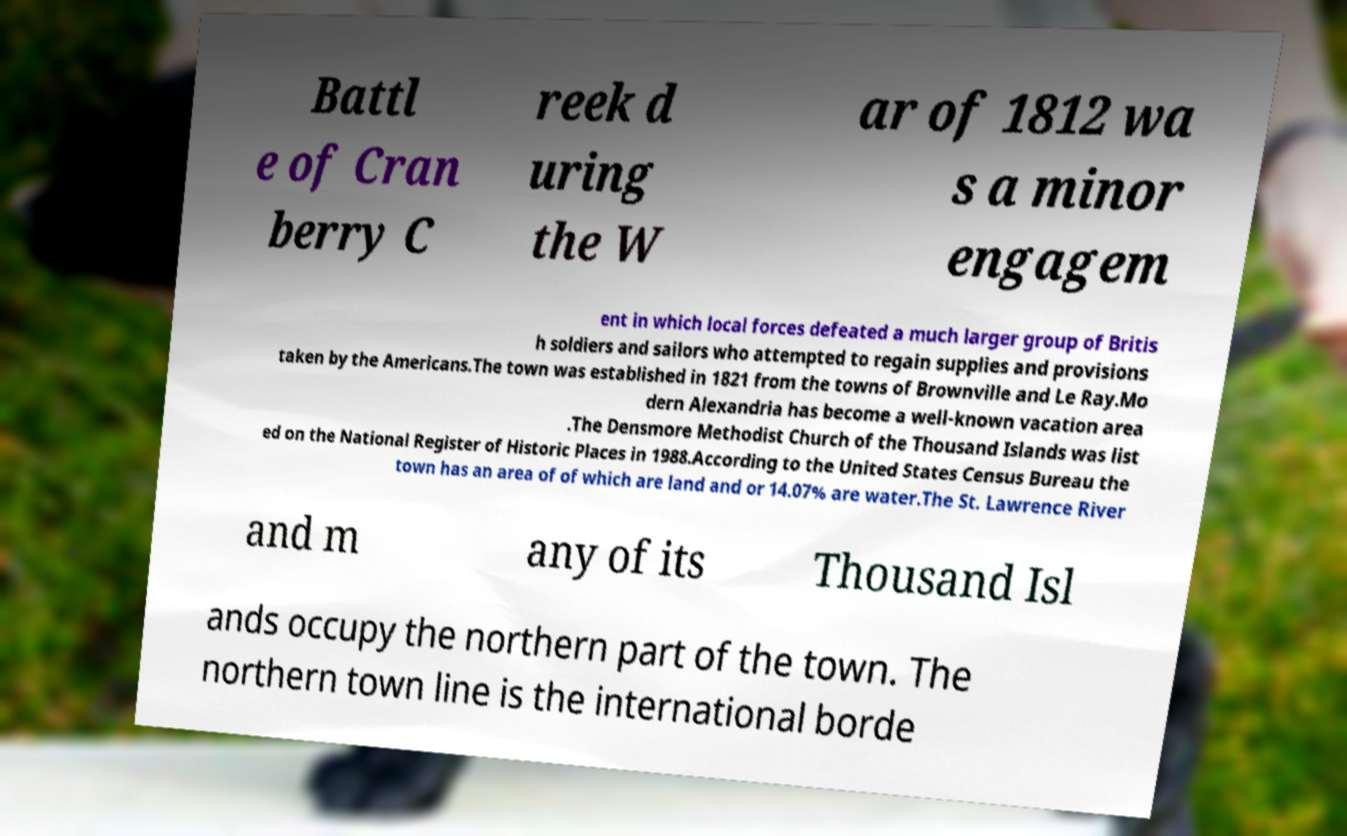Please read and relay the text visible in this image. What does it say? Battl e of Cran berry C reek d uring the W ar of 1812 wa s a minor engagem ent in which local forces defeated a much larger group of Britis h soldiers and sailors who attempted to regain supplies and provisions taken by the Americans.The town was established in 1821 from the towns of Brownville and Le Ray.Mo dern Alexandria has become a well-known vacation area .The Densmore Methodist Church of the Thousand Islands was list ed on the National Register of Historic Places in 1988.According to the United States Census Bureau the town has an area of of which are land and or 14.07% are water.The St. Lawrence River and m any of its Thousand Isl ands occupy the northern part of the town. The northern town line is the international borde 